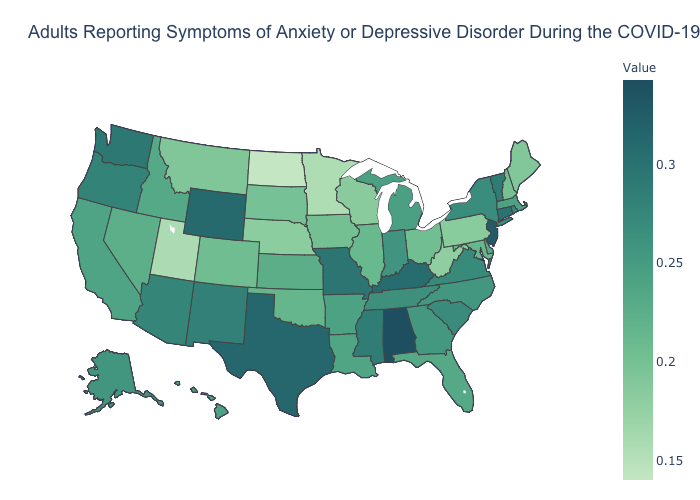Which states have the lowest value in the West?
Give a very brief answer. Utah. Does North Dakota have the lowest value in the USA?
Write a very short answer. Yes. Is the legend a continuous bar?
Give a very brief answer. Yes. Is the legend a continuous bar?
Write a very short answer. Yes. Which states hav the highest value in the South?
Quick response, please. Alabama. Does Oregon have the highest value in the USA?
Keep it brief. No. Does Indiana have the lowest value in the MidWest?
Quick response, please. No. Among the states that border Ohio , does West Virginia have the lowest value?
Give a very brief answer. Yes. 